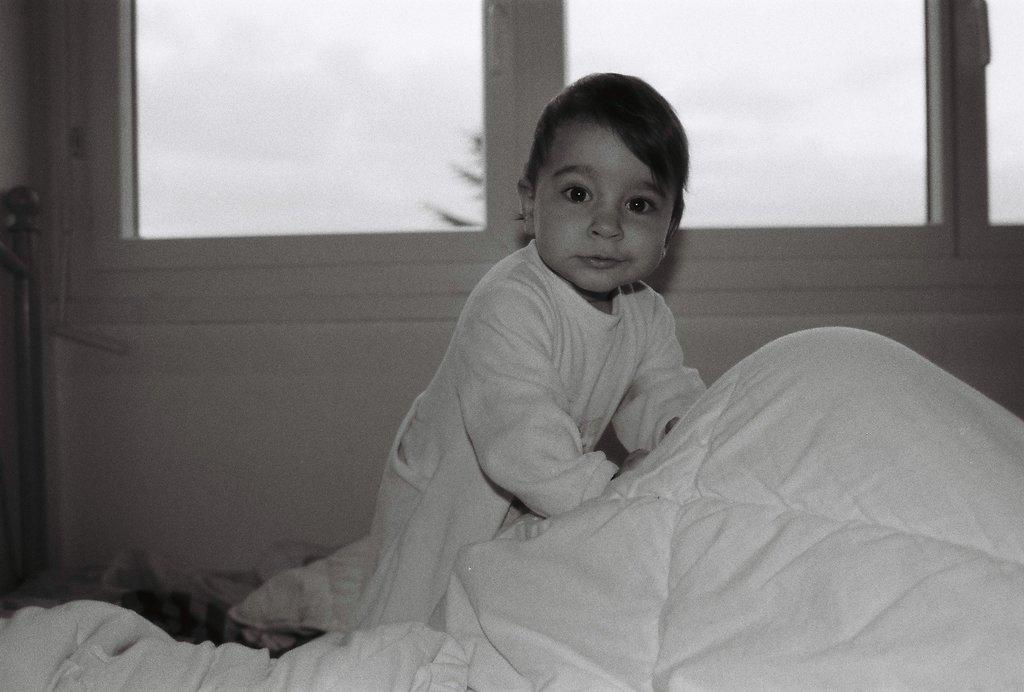What is the color scheme of the image? The image is black and white. Who or what is the main subject in the image? There is a child in the image. What can be seen in the background of the image? There are windows visible in the background of the image. What object is near the child in the image? There is a bed sheet near the child. What type of oatmeal is being served on the windowsill in the image? There is no oatmeal present in the image, and it is not being served on the windowsill. 